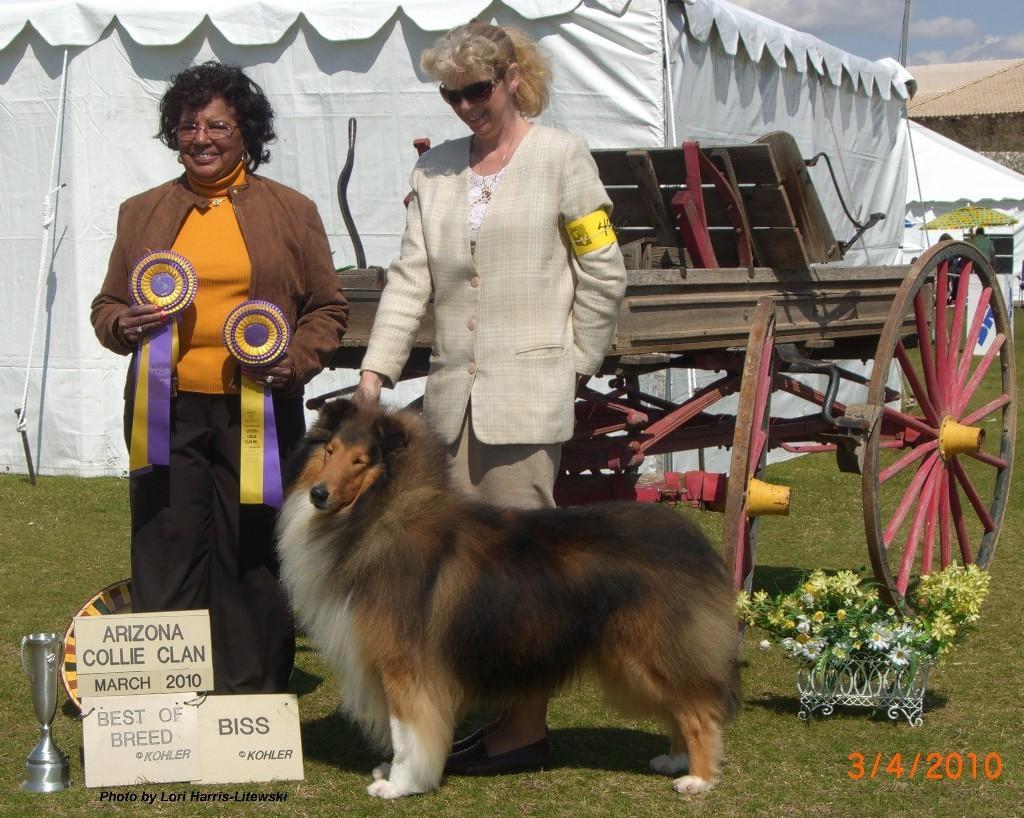Describe this image in one or two sentences. In this I can see in the middle there is a dog, a woman is standing and smiling, she wore coat. Beside her there is another woman holding the badges, on the left side there is a cup, behind them there is a cart and there are tents in white color. 